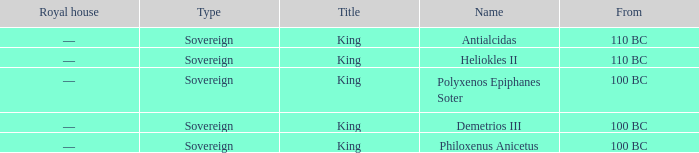When did Demetrios III begin to hold power? 100 BC. Could you parse the entire table? {'header': ['Royal house', 'Type', 'Title', 'Name', 'From'], 'rows': [['—', 'Sovereign', 'King', 'Antialcidas', '110 BC'], ['—', 'Sovereign', 'King', 'Heliokles II', '110 BC'], ['—', 'Sovereign', 'King', 'Polyxenos Epiphanes Soter', '100 BC'], ['—', 'Sovereign', 'King', 'Demetrios III', '100 BC'], ['—', 'Sovereign', 'King', 'Philoxenus Anicetus', '100 BC']]} 